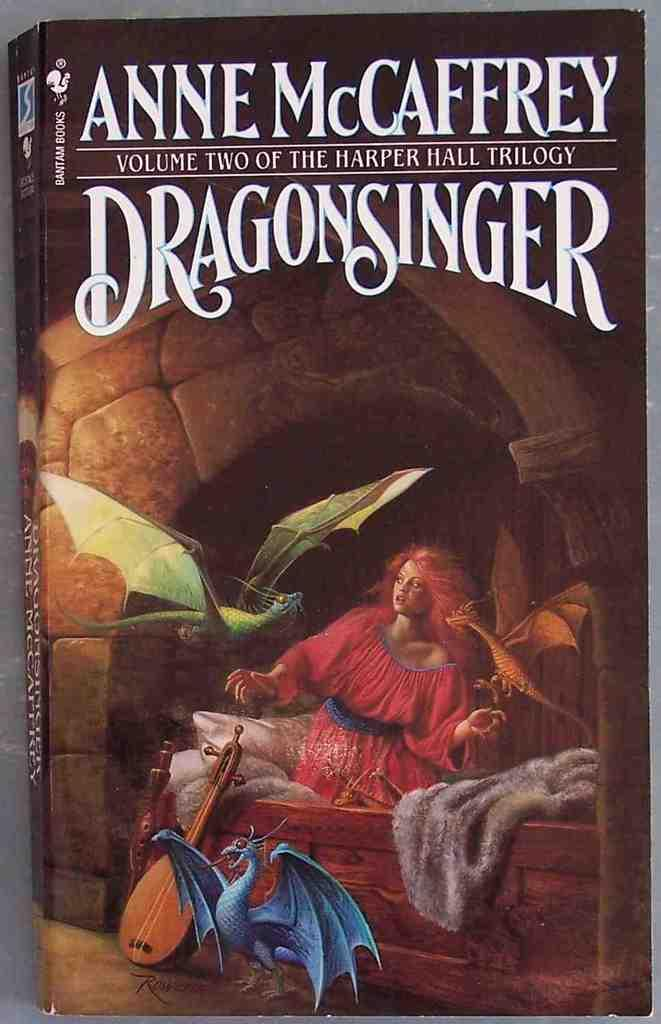<image>
Describe the image concisely. The book cover artwork for Dragonsinger by Anne McCaffrey. 